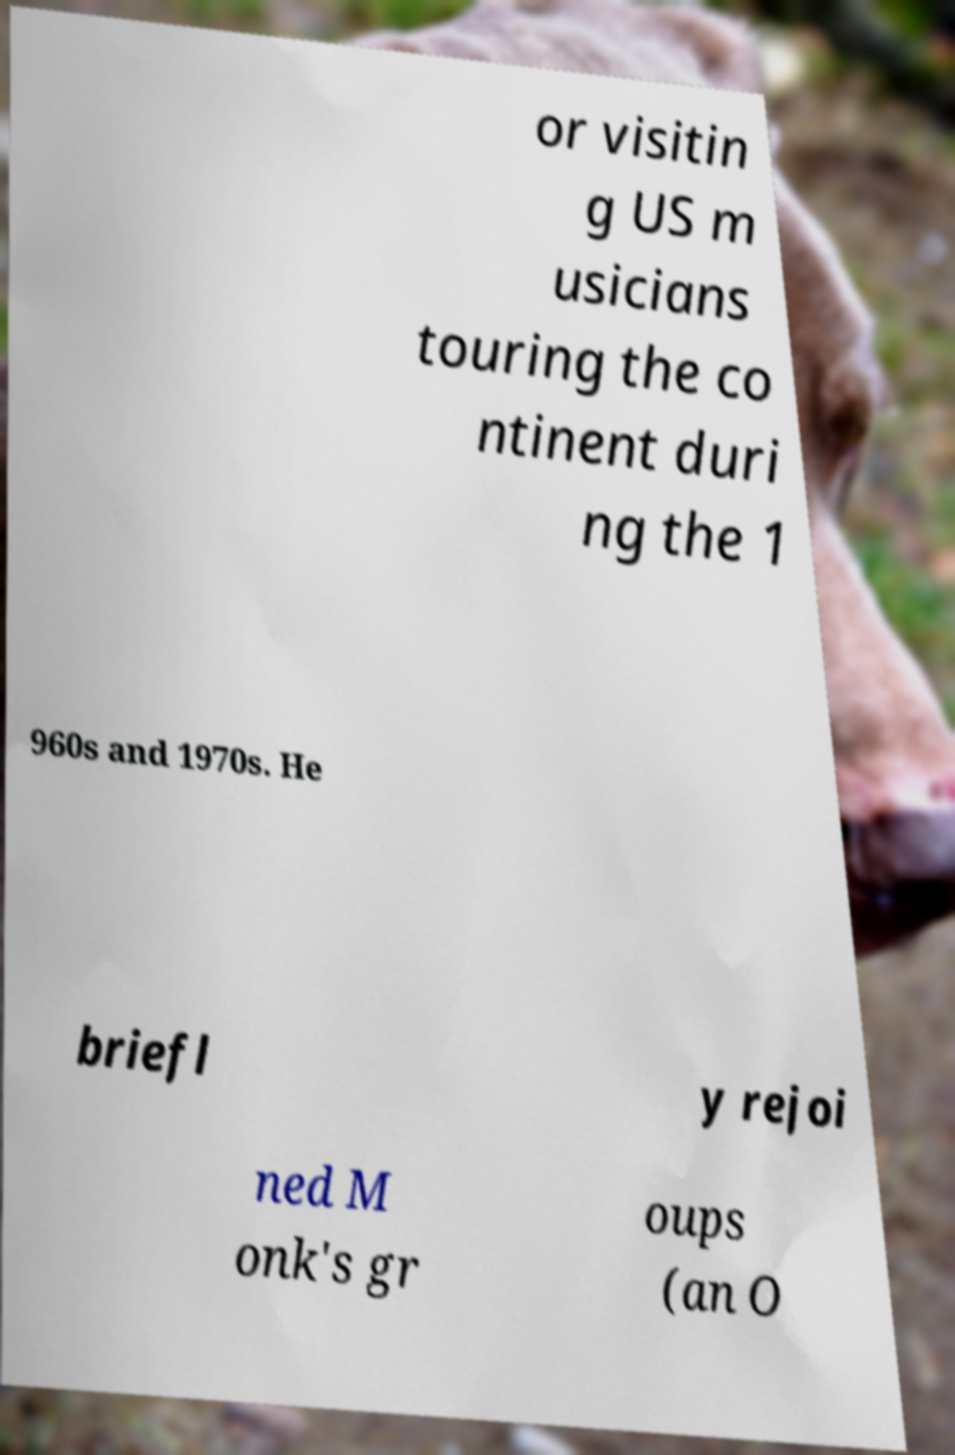Can you accurately transcribe the text from the provided image for me? or visitin g US m usicians touring the co ntinent duri ng the 1 960s and 1970s. He briefl y rejoi ned M onk's gr oups (an O 